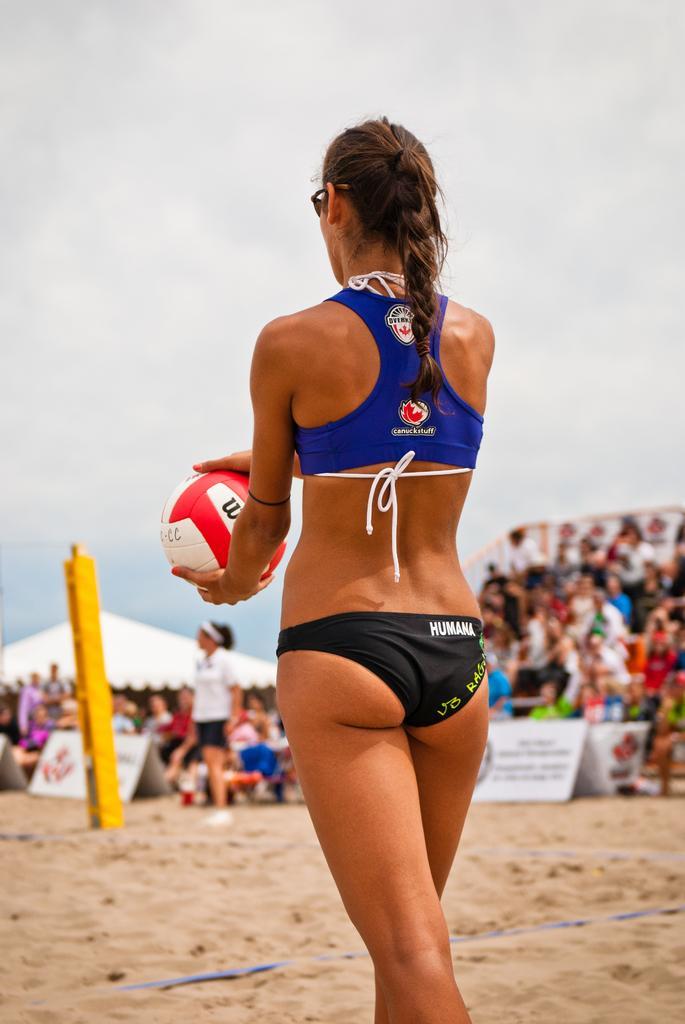Can you describe this image briefly? In the middle of the image a woman is standing and holding a ball. Behind her few people are sitting and there are some banners. Bottom left side of the image there is a pole beside the pole a woman is standing and watching. At the top of the image there are some clouds. 